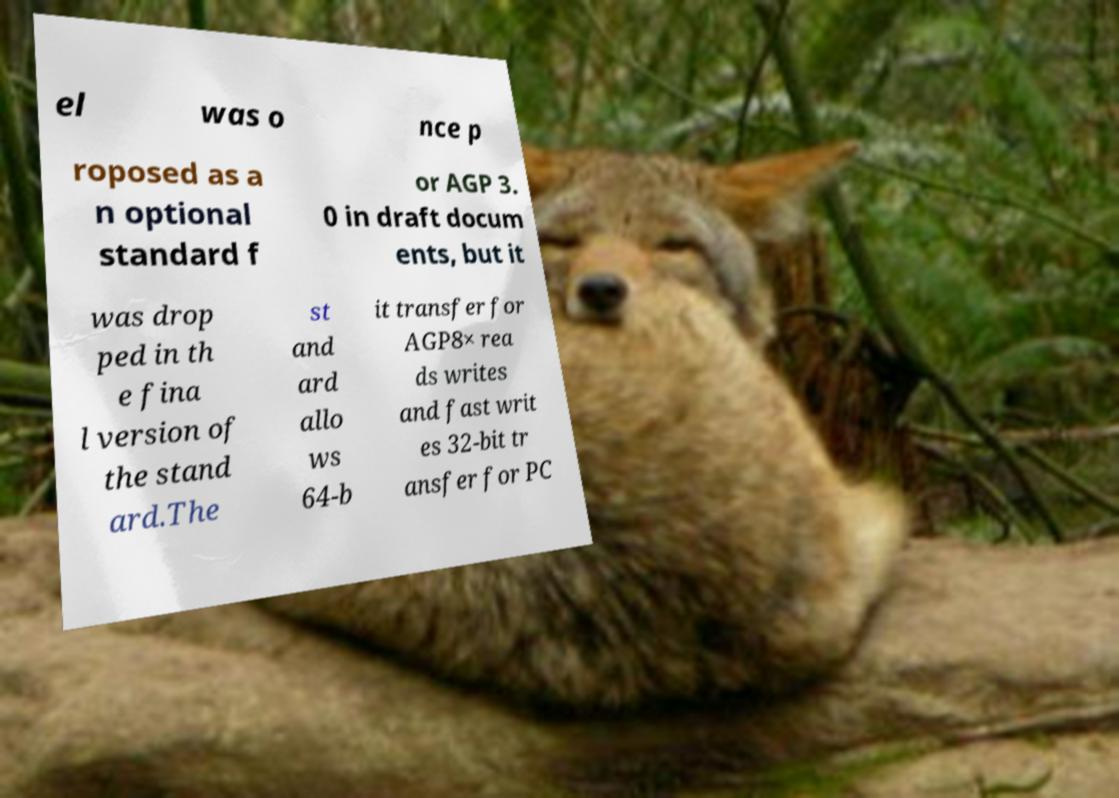What messages or text are displayed in this image? I need them in a readable, typed format. el was o nce p roposed as a n optional standard f or AGP 3. 0 in draft docum ents, but it was drop ped in th e fina l version of the stand ard.The st and ard allo ws 64-b it transfer for AGP8× rea ds writes and fast writ es 32-bit tr ansfer for PC 